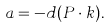<formula> <loc_0><loc_0><loc_500><loc_500>a = - d ( P \cdot k ) .</formula> 